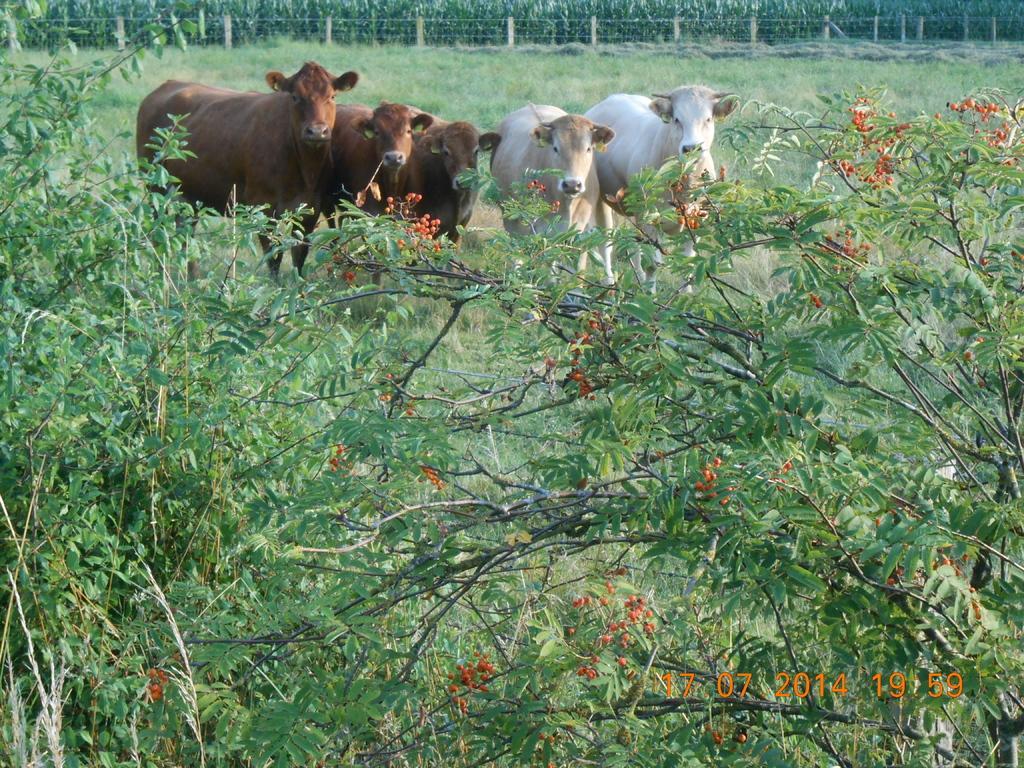Can you describe this image briefly? In the picture I can see animals are standing on the ground. I can also see trees, grass and fence. On the bottom right side of the image I can see a watermark. 